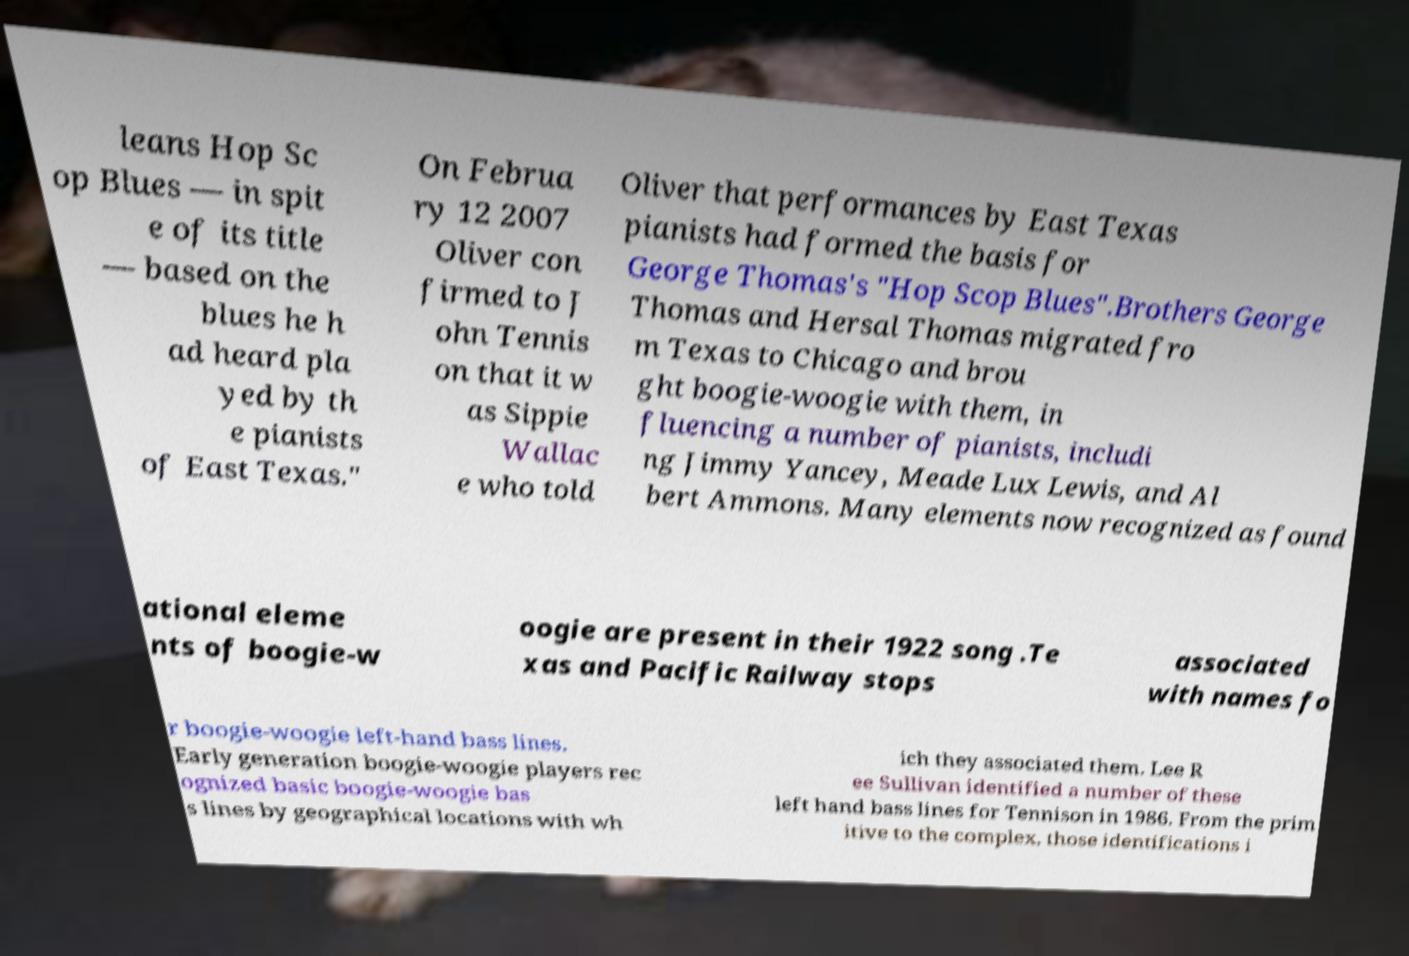Please identify and transcribe the text found in this image. leans Hop Sc op Blues — in spit e of its title — based on the blues he h ad heard pla yed by th e pianists of East Texas." On Februa ry 12 2007 Oliver con firmed to J ohn Tennis on that it w as Sippie Wallac e who told Oliver that performances by East Texas pianists had formed the basis for George Thomas's "Hop Scop Blues".Brothers George Thomas and Hersal Thomas migrated fro m Texas to Chicago and brou ght boogie-woogie with them, in fluencing a number of pianists, includi ng Jimmy Yancey, Meade Lux Lewis, and Al bert Ammons. Many elements now recognized as found ational eleme nts of boogie-w oogie are present in their 1922 song .Te xas and Pacific Railway stops associated with names fo r boogie-woogie left-hand bass lines. Early generation boogie-woogie players rec ognized basic boogie-woogie bas s lines by geographical locations with wh ich they associated them. Lee R ee Sullivan identified a number of these left hand bass lines for Tennison in 1986. From the prim itive to the complex, those identifications i 